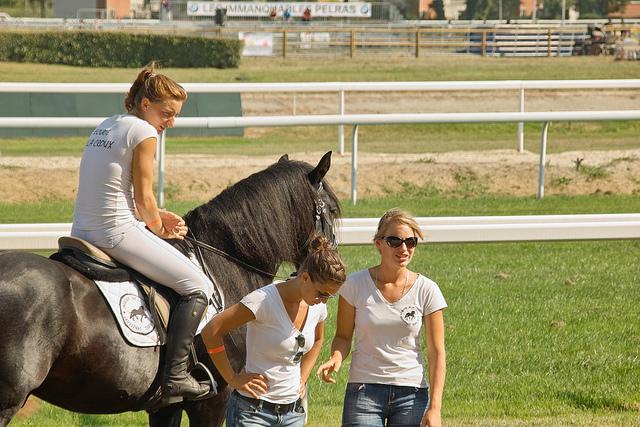What color are the girls shirts?
Quick response, please. White. Does using the animal depicted help keep these ladies slender?
Write a very short answer. Yes. Is the grass healthy?
Answer briefly. Yes. 